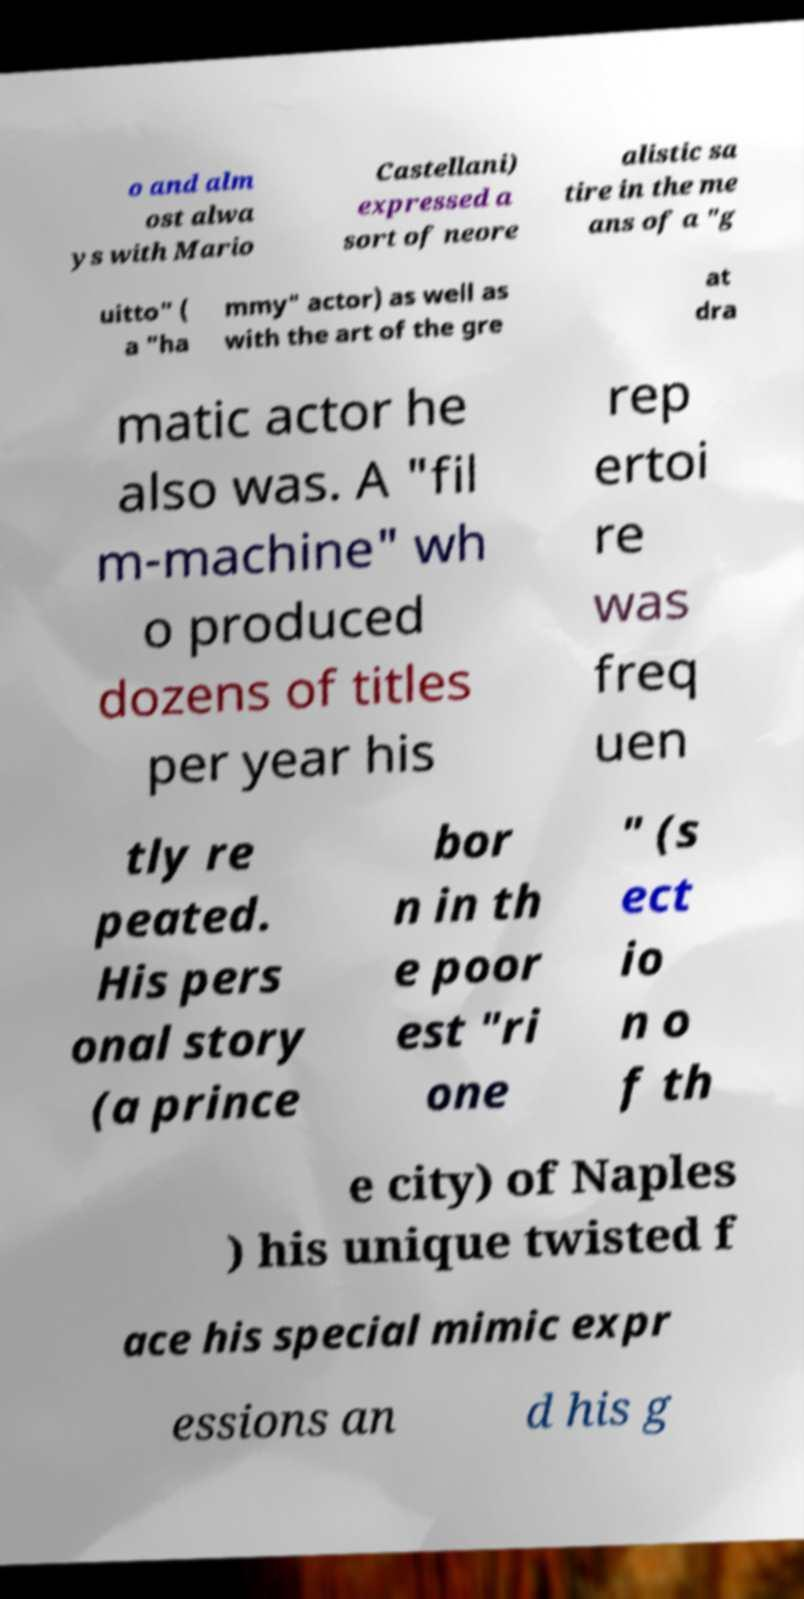Please read and relay the text visible in this image. What does it say? o and alm ost alwa ys with Mario Castellani) expressed a sort of neore alistic sa tire in the me ans of a "g uitto" ( a "ha mmy" actor) as well as with the art of the gre at dra matic actor he also was. A "fil m-machine" wh o produced dozens of titles per year his rep ertoi re was freq uen tly re peated. His pers onal story (a prince bor n in th e poor est "ri one " (s ect io n o f th e city) of Naples ) his unique twisted f ace his special mimic expr essions an d his g 